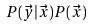<formula> <loc_0><loc_0><loc_500><loc_500>P ( \vec { y } | \vec { x } ) P ( \vec { x } )</formula> 